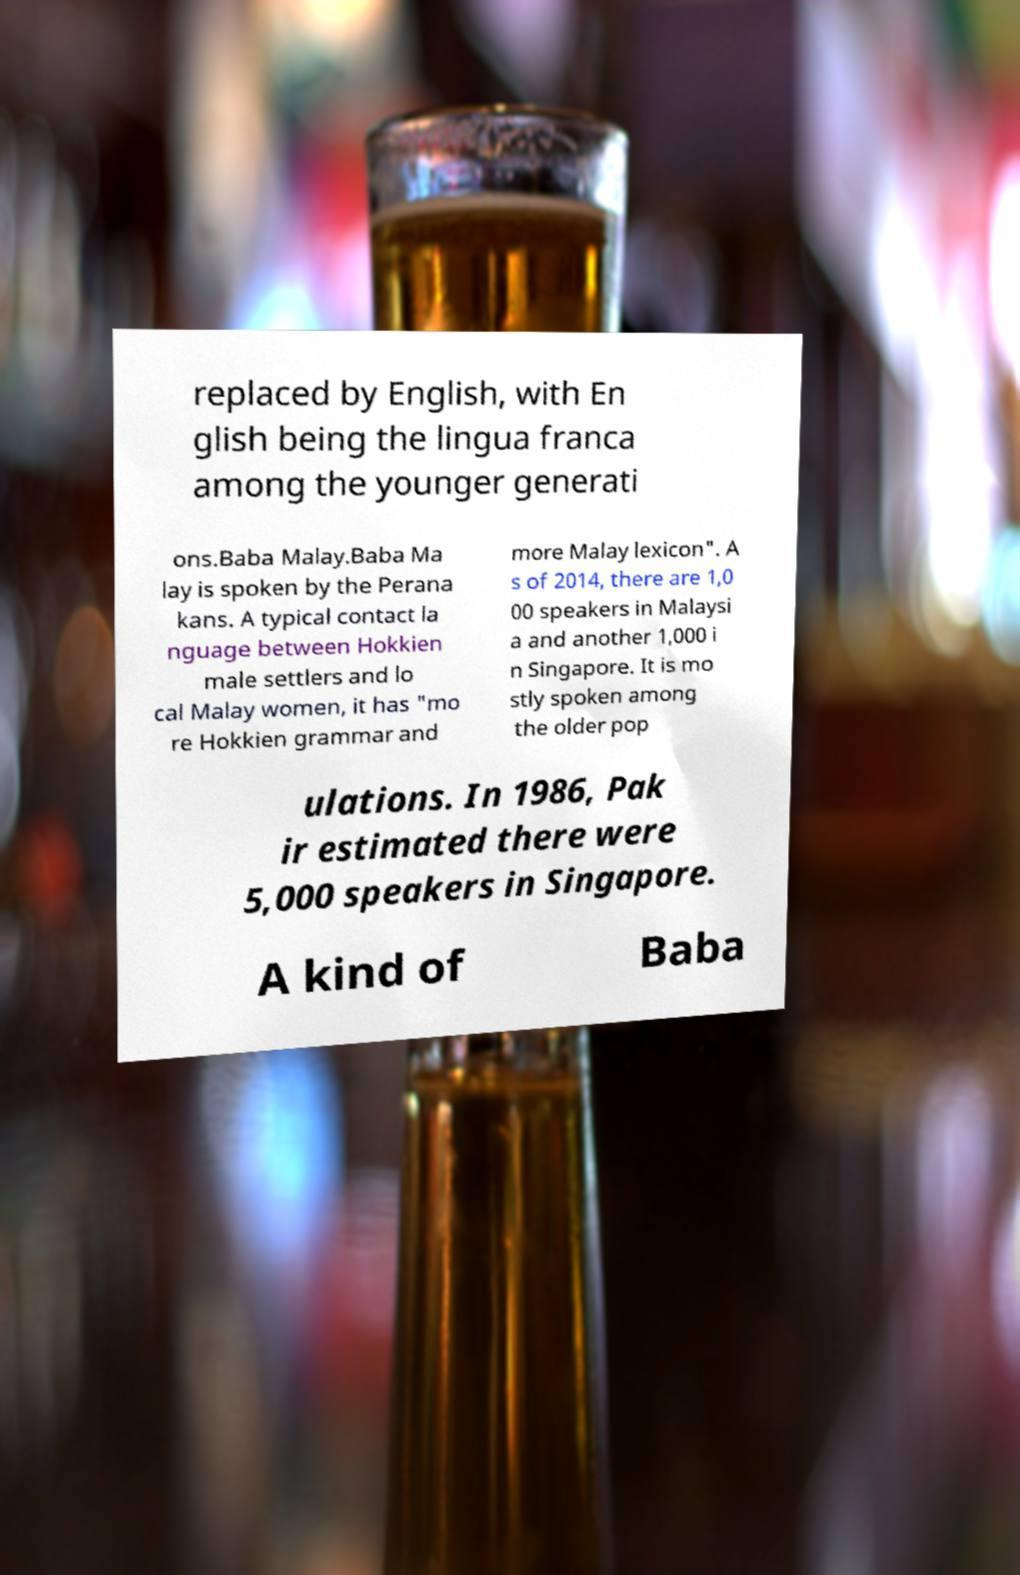Please identify and transcribe the text found in this image. replaced by English, with En glish being the lingua franca among the younger generati ons.Baba Malay.Baba Ma lay is spoken by the Perana kans. A typical contact la nguage between Hokkien male settlers and lo cal Malay women, it has "mo re Hokkien grammar and more Malay lexicon". A s of 2014, there are 1,0 00 speakers in Malaysi a and another 1,000 i n Singapore. It is mo stly spoken among the older pop ulations. In 1986, Pak ir estimated there were 5,000 speakers in Singapore. A kind of Baba 